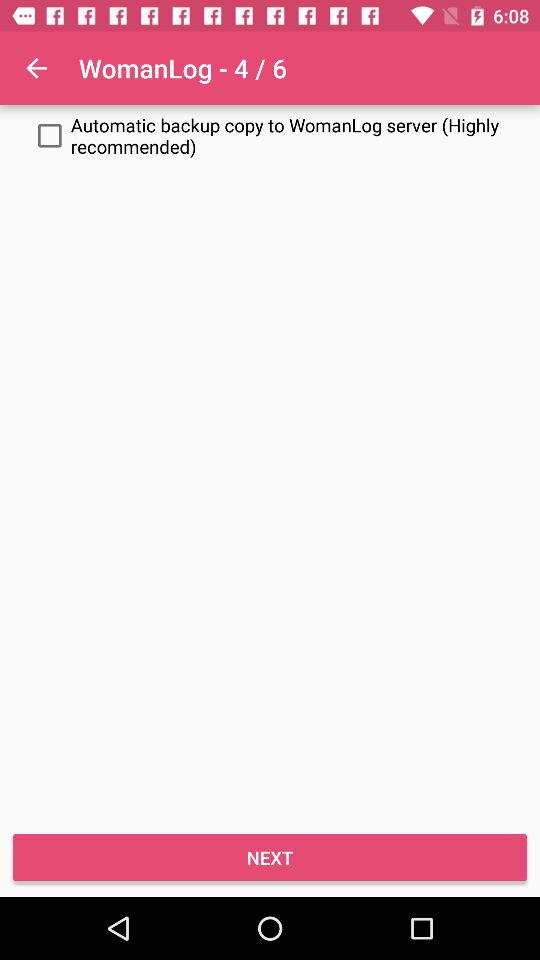What is the status of the "Automatic backup copy to WomanLog" server? The status is off. 